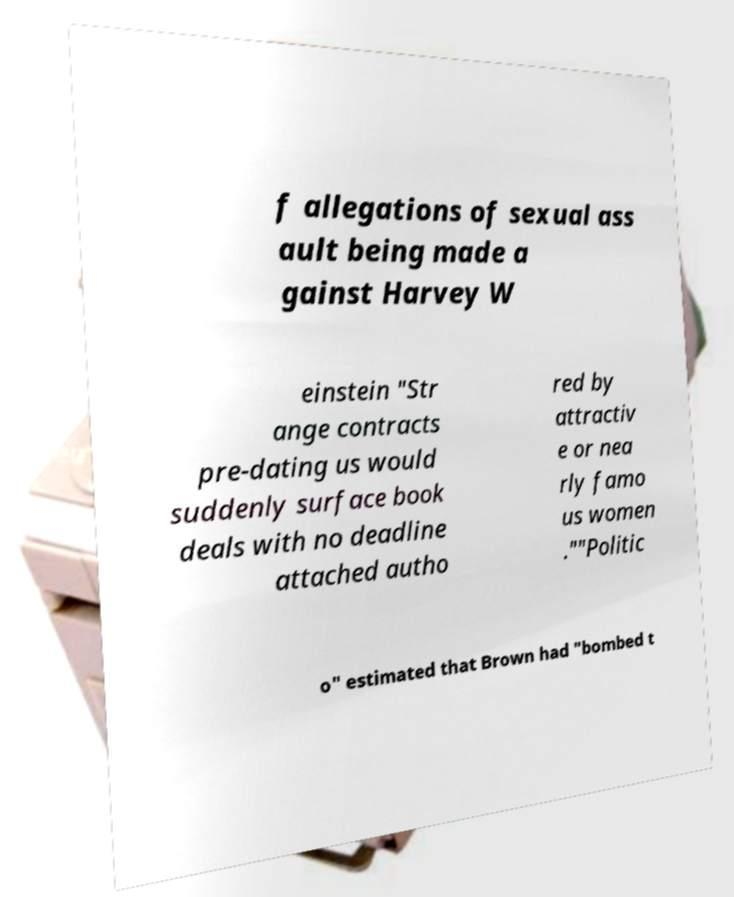Please read and relay the text visible in this image. What does it say? f allegations of sexual ass ault being made a gainst Harvey W einstein "Str ange contracts pre-dating us would suddenly surface book deals with no deadline attached autho red by attractiv e or nea rly famo us women .""Politic o" estimated that Brown had "bombed t 